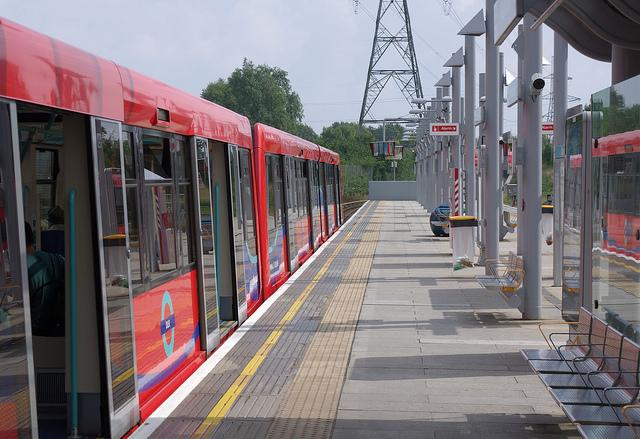What will the train do next?

Choices:
A) evacuate passengers
B) move
C) close doors
D) power off close doors 